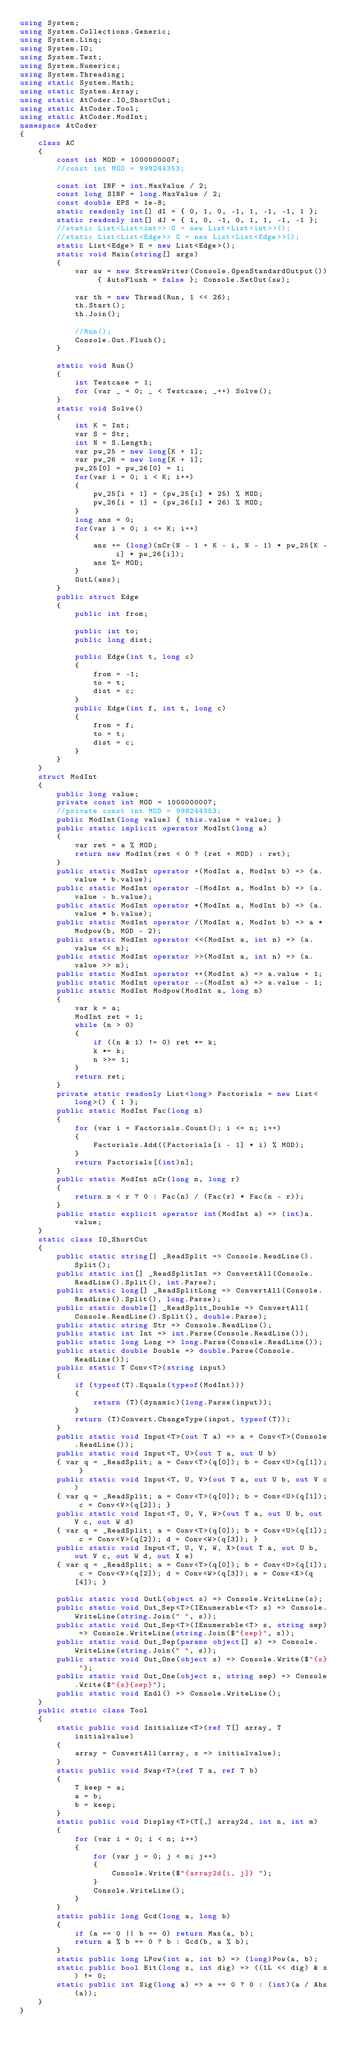<code> <loc_0><loc_0><loc_500><loc_500><_C#_>using System;
using System.Collections.Generic;
using System.Linq;
using System.IO;
using System.Text;
using System.Numerics;
using System.Threading;
using static System.Math;
using static System.Array;
using static AtCoder.IO_ShortCut;
using static AtCoder.Tool;
using static AtCoder.ModInt;
namespace AtCoder
{
    class AC
    {
        const int MOD = 1000000007;
        //const int MOD = 998244353;

        const int INF = int.MaxValue / 2;
        const long SINF = long.MaxValue / 2;
        const double EPS = 1e-8;
        static readonly int[] dI = { 0, 1, 0, -1, 1, -1, -1, 1 };
        static readonly int[] dJ = { 1, 0, -1, 0, 1, 1, -1, -1 };
        //static List<List<int>> G = new List<List<int>>();
        //static List<List<Edge>> G = new List<List<Edge>>();
        static List<Edge> E = new List<Edge>();
        static void Main(string[] args)
        {
            var sw = new StreamWriter(Console.OpenStandardOutput()) { AutoFlush = false }; Console.SetOut(sw);

            var th = new Thread(Run, 1 << 26);
            th.Start();
            th.Join();

            //Run();
            Console.Out.Flush();
        }

        static void Run()
        {
            int Testcase = 1;
            for (var _ = 0; _ < Testcase; _++) Solve();
        }
        static void Solve()
        {
            int K = Int;
            var S = Str;
            int N = S.Length;
            var pw_25 = new long[K + 1];
            var pw_26 = new long[K + 1];
            pw_25[0] = pw_26[0] = 1;
            for(var i = 0; i < K; i++)
            {
                pw_25[i + 1] = (pw_25[i] * 25) % MOD;
                pw_26[i + 1] = (pw_26[i] * 26) % MOD;
            }
            long ans = 0;
            for(var i = 0; i <= K; i++)
            {
                ans += (long)(nCr(N - 1 + K - i, N - 1) * pw_25[K - i] * pw_26[i]);
                ans %= MOD;
            }
            OutL(ans);
        }
        public struct Edge
        {
            public int from;

            public int to;
            public long dist;

            public Edge(int t, long c)
            {
                from = -1;
                to = t;
                dist = c;
            }
            public Edge(int f, int t, long c)
            {
                from = f;
                to = t;
                dist = c;
            }
        }
    }
    struct ModInt
    {
        public long value;
        private const int MOD = 1000000007;
        //private const int MOD = 998244353;
        public ModInt(long value) { this.value = value; }
        public static implicit operator ModInt(long a)
        {
            var ret = a % MOD;
            return new ModInt(ret < 0 ? (ret + MOD) : ret);
        }
        public static ModInt operator +(ModInt a, ModInt b) => (a.value + b.value);
        public static ModInt operator -(ModInt a, ModInt b) => (a.value - b.value);
        public static ModInt operator *(ModInt a, ModInt b) => (a.value * b.value);
        public static ModInt operator /(ModInt a, ModInt b) => a * Modpow(b, MOD - 2);
        public static ModInt operator <<(ModInt a, int n) => (a.value << n);
        public static ModInt operator >>(ModInt a, int n) => (a.value >> n);
        public static ModInt operator ++(ModInt a) => a.value + 1;
        public static ModInt operator --(ModInt a) => a.value - 1;
        public static ModInt Modpow(ModInt a, long n)
        {
            var k = a;
            ModInt ret = 1;
            while (n > 0)
            {
                if ((n & 1) != 0) ret *= k;
                k *= k;
                n >>= 1;
            }
            return ret;
        }
        private static readonly List<long> Factorials = new List<long>() { 1 };
        public static ModInt Fac(long n)
        {
            for (var i = Factorials.Count(); i <= n; i++)
            {
                Factorials.Add((Factorials[i - 1] * i) % MOD);
            }
            return Factorials[(int)n];
        }
        public static ModInt nCr(long n, long r)
        {
            return n < r ? 0 : Fac(n) / (Fac(r) * Fac(n - r));
        }
        public static explicit operator int(ModInt a) => (int)a.value;
    }
    static class IO_ShortCut
    {
        public static string[] _ReadSplit => Console.ReadLine().Split();
        public static int[] _ReadSplitInt => ConvertAll(Console.ReadLine().Split(), int.Parse);
        public static long[] _ReadSplitLong => ConvertAll(Console.ReadLine().Split(), long.Parse);
        public static double[] _ReadSplit_Double => ConvertAll(Console.ReadLine().Split(), double.Parse);
        public static string Str => Console.ReadLine();
        public static int Int => int.Parse(Console.ReadLine());
        public static long Long => long.Parse(Console.ReadLine());
        public static double Double => double.Parse(Console.ReadLine());
        public static T Conv<T>(string input)
        {
            if (typeof(T).Equals(typeof(ModInt)))
            {
                return (T)(dynamic)(long.Parse(input));
            }
            return (T)Convert.ChangeType(input, typeof(T));
        }
        public static void Input<T>(out T a) => a = Conv<T>(Console.ReadLine());
        public static void Input<T, U>(out T a, out U b)
        { var q = _ReadSplit; a = Conv<T>(q[0]); b = Conv<U>(q[1]); }
        public static void Input<T, U, V>(out T a, out U b, out V c)
        { var q = _ReadSplit; a = Conv<T>(q[0]); b = Conv<U>(q[1]); c = Conv<V>(q[2]); }
        public static void Input<T, U, V, W>(out T a, out U b, out V c, out W d)
        { var q = _ReadSplit; a = Conv<T>(q[0]); b = Conv<U>(q[1]); c = Conv<V>(q[2]); d = Conv<W>(q[3]); }
        public static void Input<T, U, V, W, X>(out T a, out U b, out V c, out W d, out X e)
        { var q = _ReadSplit; a = Conv<T>(q[0]); b = Conv<U>(q[1]); c = Conv<V>(q[2]); d = Conv<W>(q[3]); e = Conv<X>(q[4]); }

        public static void OutL(object s) => Console.WriteLine(s);
        public static void Out_Sep<T>(IEnumerable<T> s) => Console.WriteLine(string.Join(" ", s));
        public static void Out_Sep<T>(IEnumerable<T> s, string sep) => Console.WriteLine(string.Join($"{sep}", s));
        public static void Out_Sep(params object[] s) => Console.WriteLine(string.Join(" ", s));
        public static void Out_One(object s) => Console.Write($"{s} ");
        public static void Out_One(object s, string sep) => Console.Write($"{s}{sep}");
        public static void Endl() => Console.WriteLine();
    }
    public static class Tool
    {
        static public void Initialize<T>(ref T[] array, T initialvalue)
        {
            array = ConvertAll(array, x => initialvalue);
        }
        static public void Swap<T>(ref T a, ref T b)
        {
            T keep = a;
            a = b;
            b = keep;
        }
        static public void Display<T>(T[,] array2d, int n, int m)
        {
            for (var i = 0; i < n; i++)
            {
                for (var j = 0; j < m; j++)
                {
                    Console.Write($"{array2d[i, j]} ");
                }
                Console.WriteLine();
            }
        }
        static public long Gcd(long a, long b)
        {
            if (a == 0 || b == 0) return Max(a, b);
            return a % b == 0 ? b : Gcd(b, a % b);
        }
        static public long LPow(int a, int b) => (long)Pow(a, b);
        static public bool Bit(long x, int dig) => ((1L << dig) & x) != 0;
        static public int Sig(long a) => a == 0 ? 0 : (int)(a / Abs(a));
    }
}
</code> 